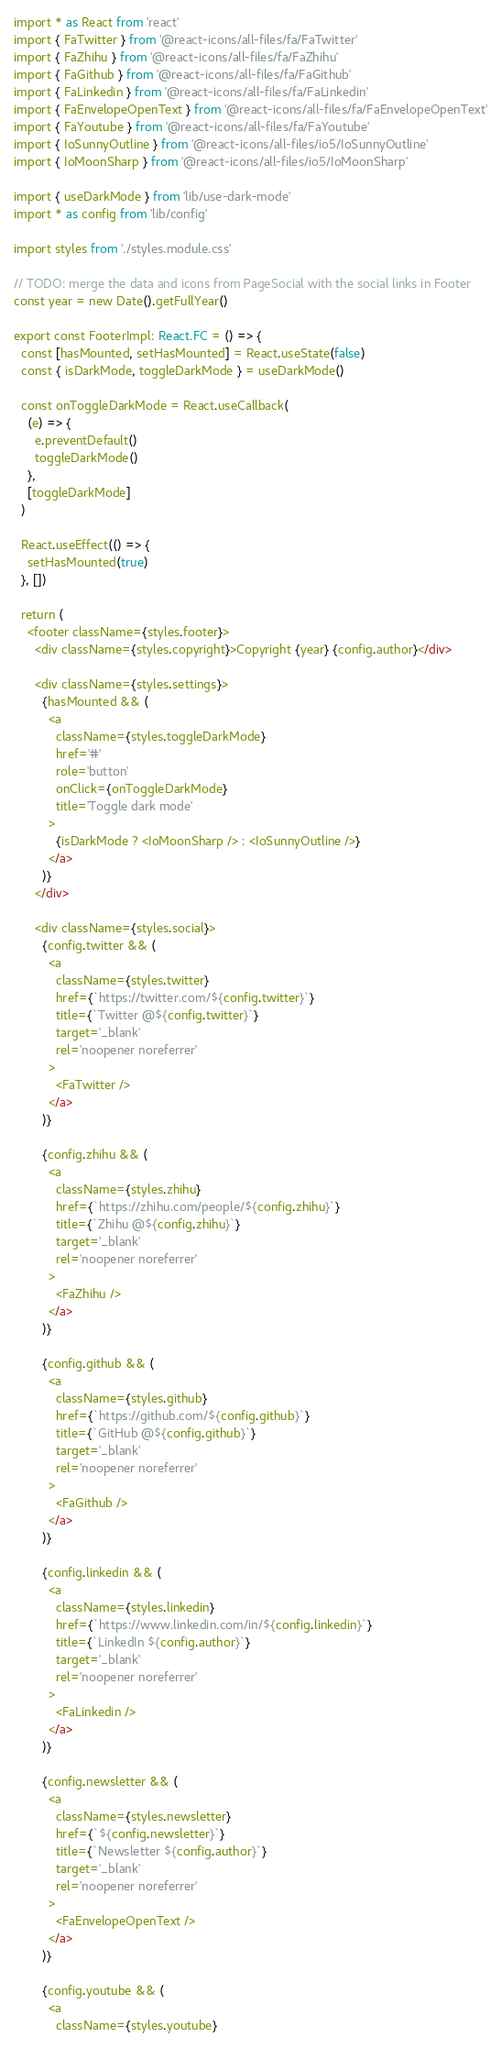Convert code to text. <code><loc_0><loc_0><loc_500><loc_500><_TypeScript_>import * as React from 'react'
import { FaTwitter } from '@react-icons/all-files/fa/FaTwitter'
import { FaZhihu } from '@react-icons/all-files/fa/FaZhihu'
import { FaGithub } from '@react-icons/all-files/fa/FaGithub'
import { FaLinkedin } from '@react-icons/all-files/fa/FaLinkedin'
import { FaEnvelopeOpenText } from '@react-icons/all-files/fa/FaEnvelopeOpenText'
import { FaYoutube } from '@react-icons/all-files/fa/FaYoutube'
import { IoSunnyOutline } from '@react-icons/all-files/io5/IoSunnyOutline'
import { IoMoonSharp } from '@react-icons/all-files/io5/IoMoonSharp'

import { useDarkMode } from 'lib/use-dark-mode'
import * as config from 'lib/config'

import styles from './styles.module.css'

// TODO: merge the data and icons from PageSocial with the social links in Footer
const year = new Date().getFullYear()

export const FooterImpl: React.FC = () => {
  const [hasMounted, setHasMounted] = React.useState(false)
  const { isDarkMode, toggleDarkMode } = useDarkMode()

  const onToggleDarkMode = React.useCallback(
    (e) => {
      e.preventDefault()
      toggleDarkMode()
    },
    [toggleDarkMode]
  )

  React.useEffect(() => {
    setHasMounted(true)
  }, [])

  return (
    <footer className={styles.footer}>
      <div className={styles.copyright}>Copyright {year} {config.author}</div>

      <div className={styles.settings}>
        {hasMounted && (
          <a
            className={styles.toggleDarkMode}
            href='#'
            role='button'
            onClick={onToggleDarkMode}
            title='Toggle dark mode'
          >
            {isDarkMode ? <IoMoonSharp /> : <IoSunnyOutline />}
          </a>
        )}
      </div>

      <div className={styles.social}>
        {config.twitter && (
          <a
            className={styles.twitter}
            href={`https://twitter.com/${config.twitter}`}
            title={`Twitter @${config.twitter}`}
            target='_blank'
            rel='noopener noreferrer'
          >
            <FaTwitter />
          </a>
        )}

        {config.zhihu && (
          <a
            className={styles.zhihu}
            href={`https://zhihu.com/people/${config.zhihu}`}
            title={`Zhihu @${config.zhihu}`}
            target='_blank'
            rel='noopener noreferrer'
          >
            <FaZhihu />
          </a>
        )}

        {config.github && (
          <a
            className={styles.github}
            href={`https://github.com/${config.github}`}
            title={`GitHub @${config.github}`}
            target='_blank'
            rel='noopener noreferrer'
          >
            <FaGithub />
          </a>
        )}

        {config.linkedin && (
          <a
            className={styles.linkedin}
            href={`https://www.linkedin.com/in/${config.linkedin}`}
            title={`LinkedIn ${config.author}`}
            target='_blank'
            rel='noopener noreferrer'
          >
            <FaLinkedin />
          </a>
        )}

        {config.newsletter && (
          <a
            className={styles.newsletter}
            href={`${config.newsletter}`}
            title={`Newsletter ${config.author}`}
            target='_blank'
            rel='noopener noreferrer'
          >
            <FaEnvelopeOpenText />
          </a>
        )}

        {config.youtube && (
          <a
            className={styles.youtube}</code> 